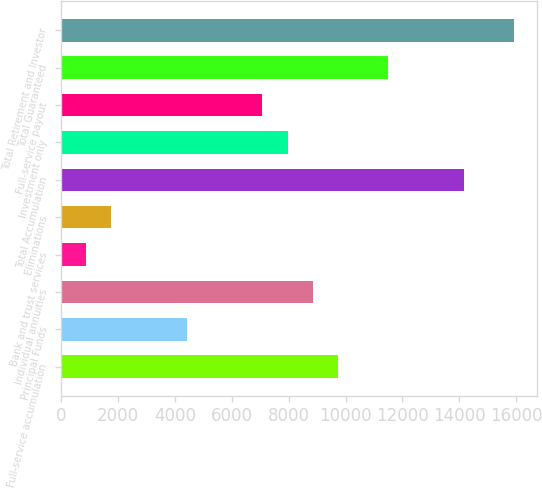Convert chart. <chart><loc_0><loc_0><loc_500><loc_500><bar_chart><fcel>Full-service accumulation<fcel>Principal Funds<fcel>Individual annuities<fcel>Bank and trust services<fcel>Eliminations<fcel>Total Accumulation<fcel>Investment only<fcel>Full-service payout<fcel>Total Guaranteed<fcel>Total Retirement and Investor<nl><fcel>9733.96<fcel>4424.8<fcel>8849.1<fcel>885.36<fcel>1770.22<fcel>14158.3<fcel>7964.24<fcel>7079.38<fcel>11503.7<fcel>15928<nl></chart> 